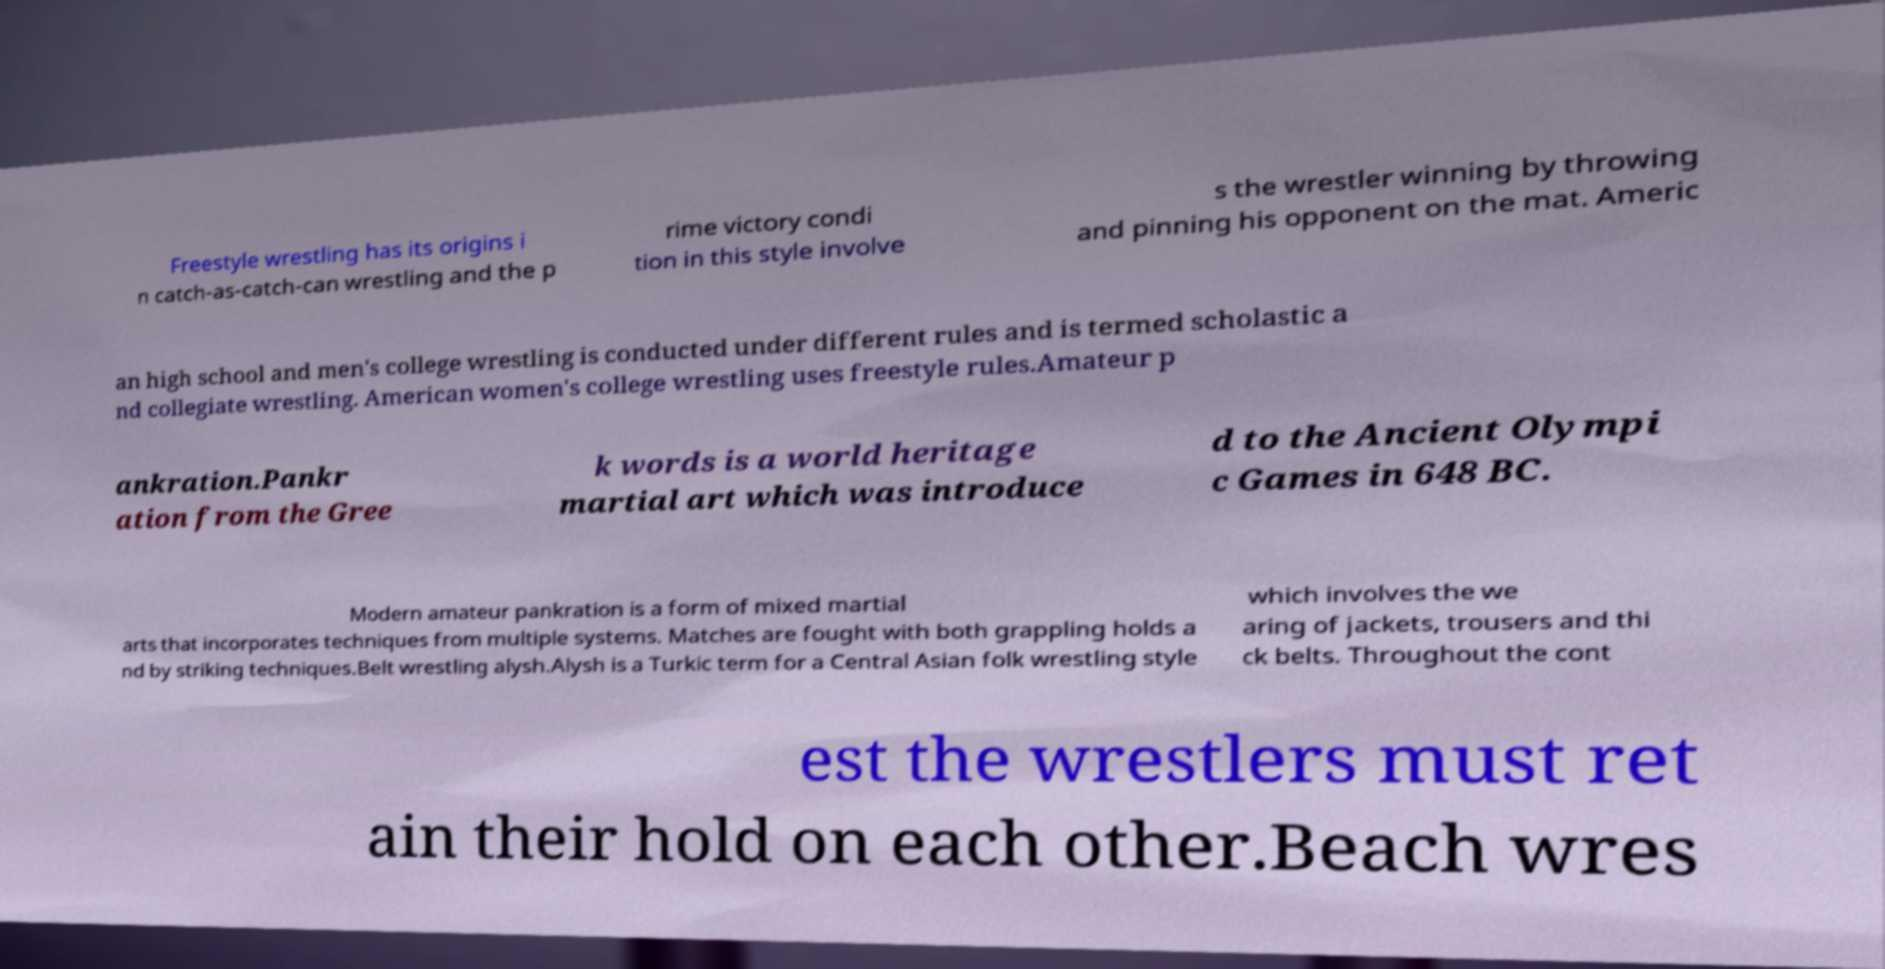For documentation purposes, I need the text within this image transcribed. Could you provide that? Freestyle wrestling has its origins i n catch-as-catch-can wrestling and the p rime victory condi tion in this style involve s the wrestler winning by throwing and pinning his opponent on the mat. Americ an high school and men's college wrestling is conducted under different rules and is termed scholastic a nd collegiate wrestling. American women's college wrestling uses freestyle rules.Amateur p ankration.Pankr ation from the Gree k words is a world heritage martial art which was introduce d to the Ancient Olympi c Games in 648 BC. Modern amateur pankration is a form of mixed martial arts that incorporates techniques from multiple systems. Matches are fought with both grappling holds a nd by striking techniques.Belt wrestling alysh.Alysh is a Turkic term for a Central Asian folk wrestling style which involves the we aring of jackets, trousers and thi ck belts. Throughout the cont est the wrestlers must ret ain their hold on each other.Beach wres 